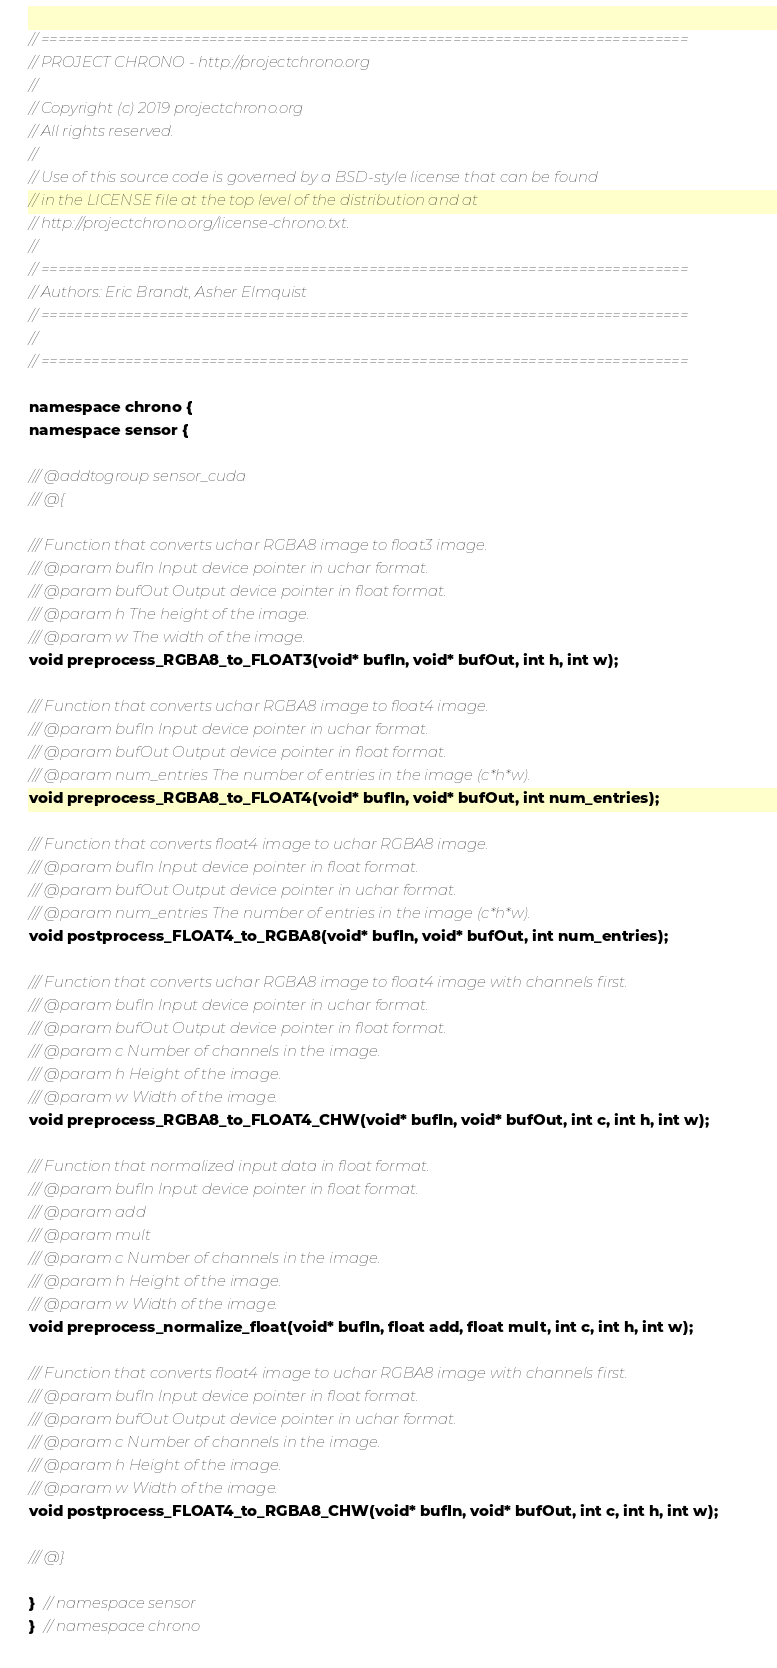Convert code to text. <code><loc_0><loc_0><loc_500><loc_500><_Cuda_>// =============================================================================
// PROJECT CHRONO - http://projectchrono.org
//
// Copyright (c) 2019 projectchrono.org
// All rights reserved.
//
// Use of this source code is governed by a BSD-style license that can be found
// in the LICENSE file at the top level of the distribution and at
// http://projectchrono.org/license-chrono.txt.
//
// =============================================================================
// Authors: Eric Brandt, Asher Elmquist
// =============================================================================
//
// =============================================================================

namespace chrono {
namespace sensor {

/// @addtogroup sensor_cuda
/// @{

/// Function that converts uchar RGBA8 image to float3 image.
/// @param bufIn Input device pointer in uchar format.
/// @param bufOut Output device pointer in float format.
/// @param h The height of the image.
/// @param w The width of the image.
void preprocess_RGBA8_to_FLOAT3(void* bufIn, void* bufOut, int h, int w);

/// Function that converts uchar RGBA8 image to float4 image.
/// @param bufIn Input device pointer in uchar format.
/// @param bufOut Output device pointer in float format.
/// @param num_entries The number of entries in the image (c*h*w).
void preprocess_RGBA8_to_FLOAT4(void* bufIn, void* bufOut, int num_entries);

/// Function that converts float4 image to uchar RGBA8 image.
/// @param bufIn Input device pointer in float format.
/// @param bufOut Output device pointer in uchar format.
/// @param num_entries The number of entries in the image (c*h*w).
void postprocess_FLOAT4_to_RGBA8(void* bufIn, void* bufOut, int num_entries);

/// Function that converts uchar RGBA8 image to float4 image with channels first.
/// @param bufIn Input device pointer in uchar format.
/// @param bufOut Output device pointer in float format.
/// @param c Number of channels in the image.
/// @param h Height of the image.
/// @param w Width of the image.
void preprocess_RGBA8_to_FLOAT4_CHW(void* bufIn, void* bufOut, int c, int h, int w);

/// Function that normalized input data in float format.
/// @param bufIn Input device pointer in float format.
/// @param add
/// @param mult
/// @param c Number of channels in the image.
/// @param h Height of the image.
/// @param w Width of the image.
void preprocess_normalize_float(void* bufIn, float add, float mult, int c, int h, int w);

/// Function that converts float4 image to uchar RGBA8 image with channels first.
/// @param bufIn Input device pointer in float format.
/// @param bufOut Output device pointer in uchar format.
/// @param c Number of channels in the image.
/// @param h Height of the image.
/// @param w Width of the image.
void postprocess_FLOAT4_to_RGBA8_CHW(void* bufIn, void* bufOut, int c, int h, int w);

/// @}

}  // namespace sensor
}  // namespace chrono
</code> 